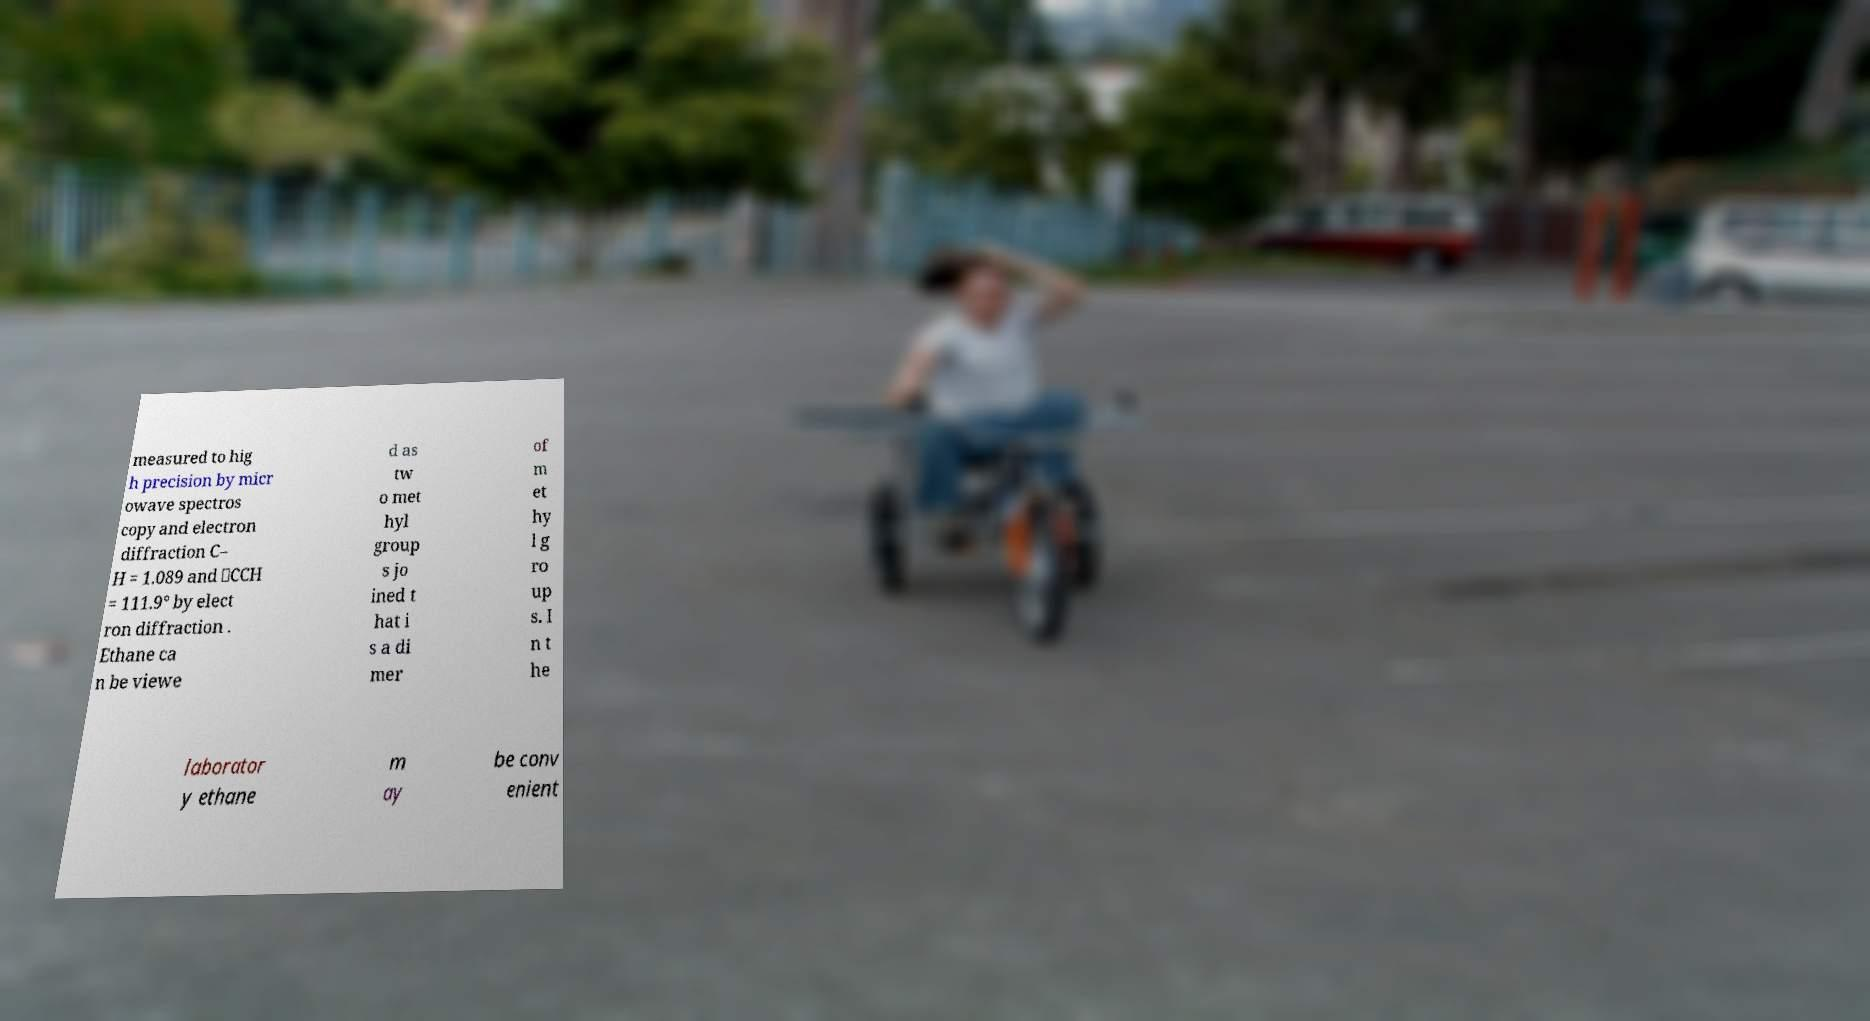Could you extract and type out the text from this image? measured to hig h precision by micr owave spectros copy and electron diffraction C– H = 1.089 and ∠CCH = 111.9° by elect ron diffraction . Ethane ca n be viewe d as tw o met hyl group s jo ined t hat i s a di mer of m et hy l g ro up s. I n t he laborator y ethane m ay be conv enient 